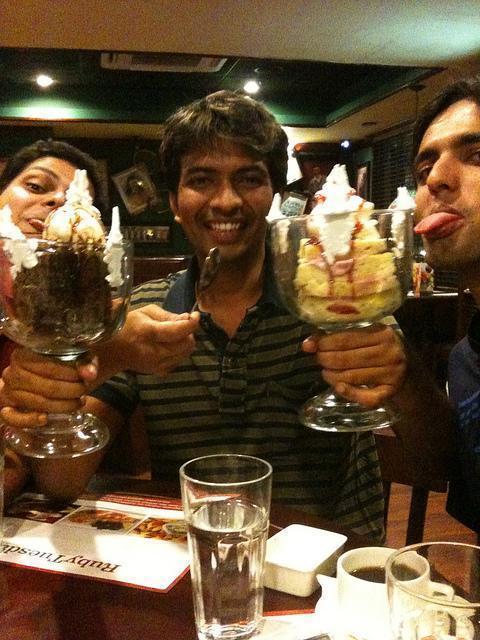In what year did this company exit bankruptcy?
Choose the right answer from the provided options to respond to the question.
Options: 2016, 2014, 2008, 2021. 2021. 